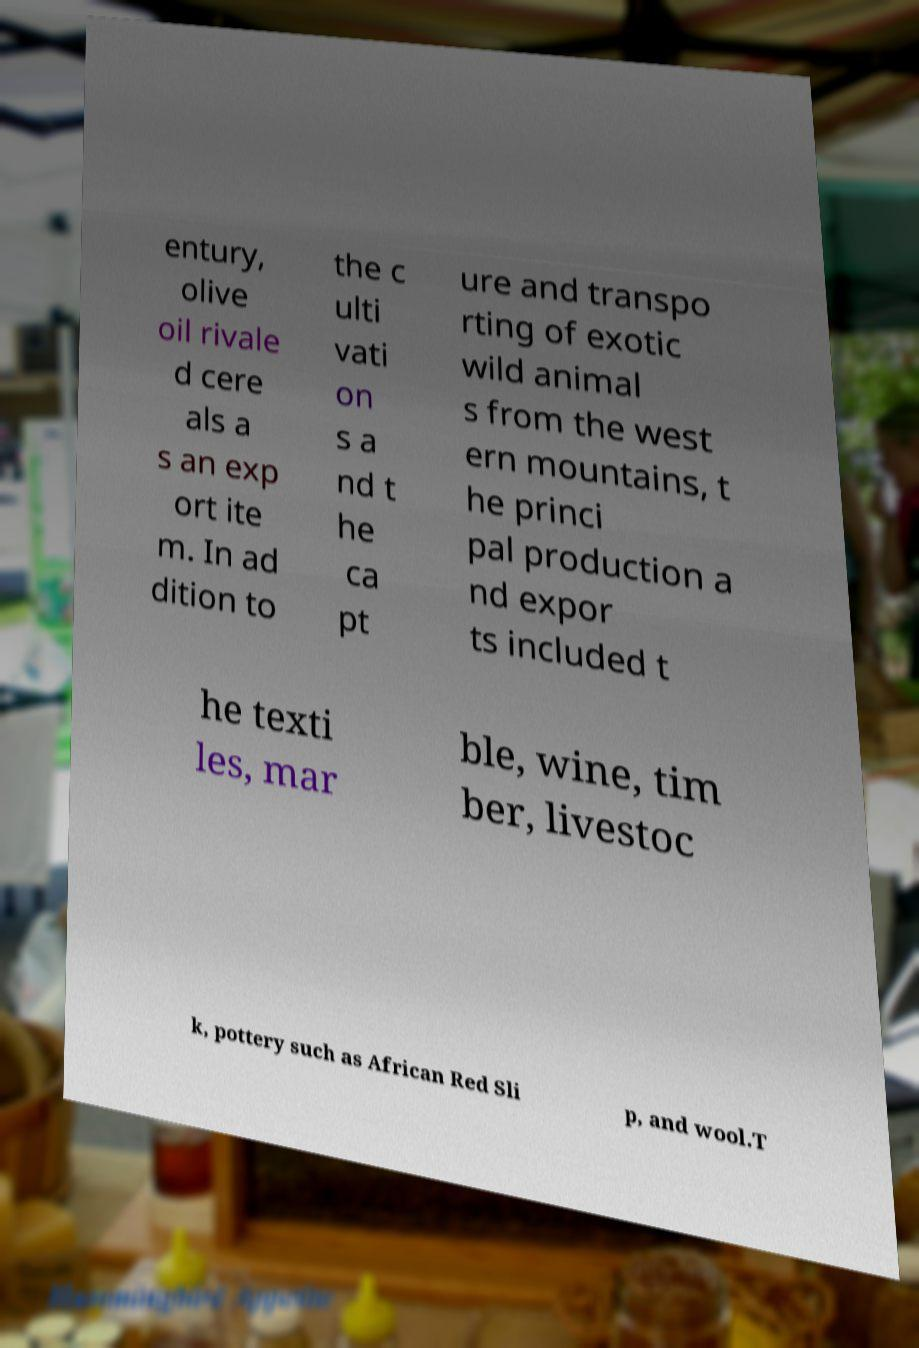For documentation purposes, I need the text within this image transcribed. Could you provide that? entury, olive oil rivale d cere als a s an exp ort ite m. In ad dition to the c ulti vati on s a nd t he ca pt ure and transpo rting of exotic wild animal s from the west ern mountains, t he princi pal production a nd expor ts included t he texti les, mar ble, wine, tim ber, livestoc k, pottery such as African Red Sli p, and wool.T 